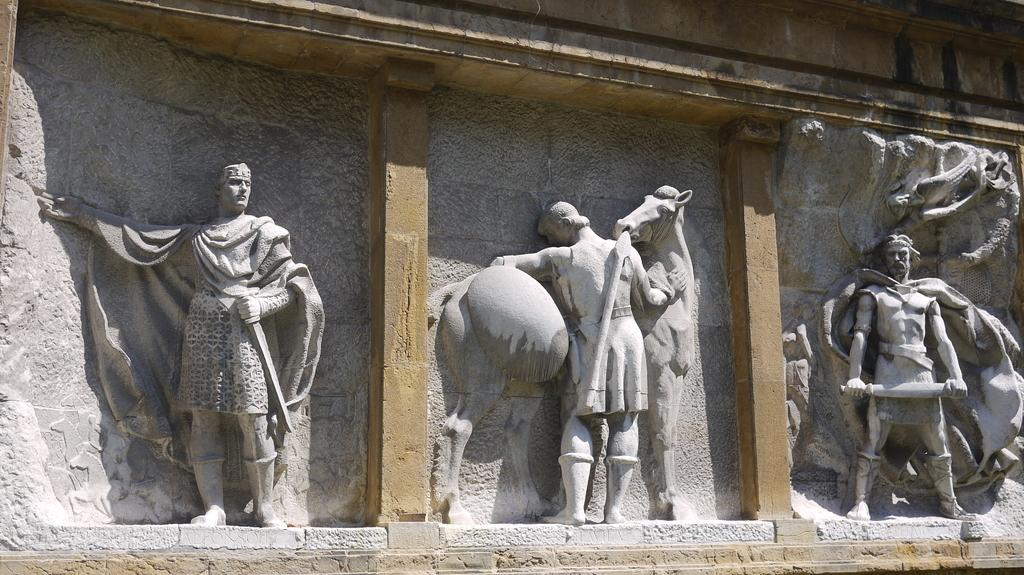What type of artwork can be seen in the image? There are sculptures in the image. What architectural features are present in the image? There are pillars and a wall in the image. What type of leather is used to create the brake on the sculpture in the image? There is no leather or brake present in the image; it features sculptures and architectural elements. 